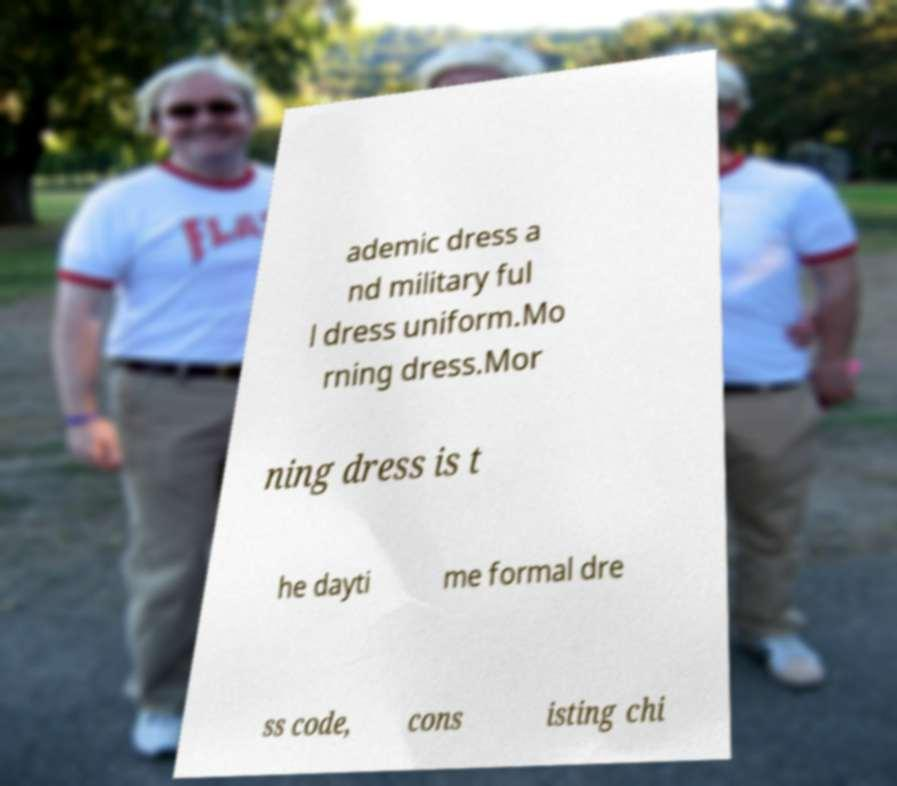What messages or text are displayed in this image? I need them in a readable, typed format. ademic dress a nd military ful l dress uniform.Mo rning dress.Mor ning dress is t he dayti me formal dre ss code, cons isting chi 